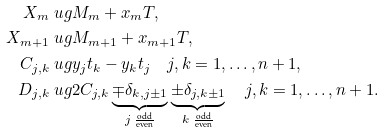<formula> <loc_0><loc_0><loc_500><loc_500>X _ { m } & \ u g M _ { m } + x _ { m } T , \\ X _ { m + 1 } & \ u g M _ { m + 1 } + x _ { m + 1 } T , \\ C _ { j , k } & \ u g y _ { j } t _ { k } - y _ { k } t _ { j } \quad j , k = 1 , \dots , n + 1 , \\ D _ { j , k } & \ u g 2 C _ { j , k } \underbrace { \mp \delta _ { k , j \pm 1 } } _ { j \text { } \frac { \text {odd} } { \text {even} } } \underbrace { \pm \delta _ { j , k \pm 1 } } _ { k \text { } \frac { \text {odd} } { \text {even} } } \quad j , k = 1 , \dots , n + 1 .</formula> 